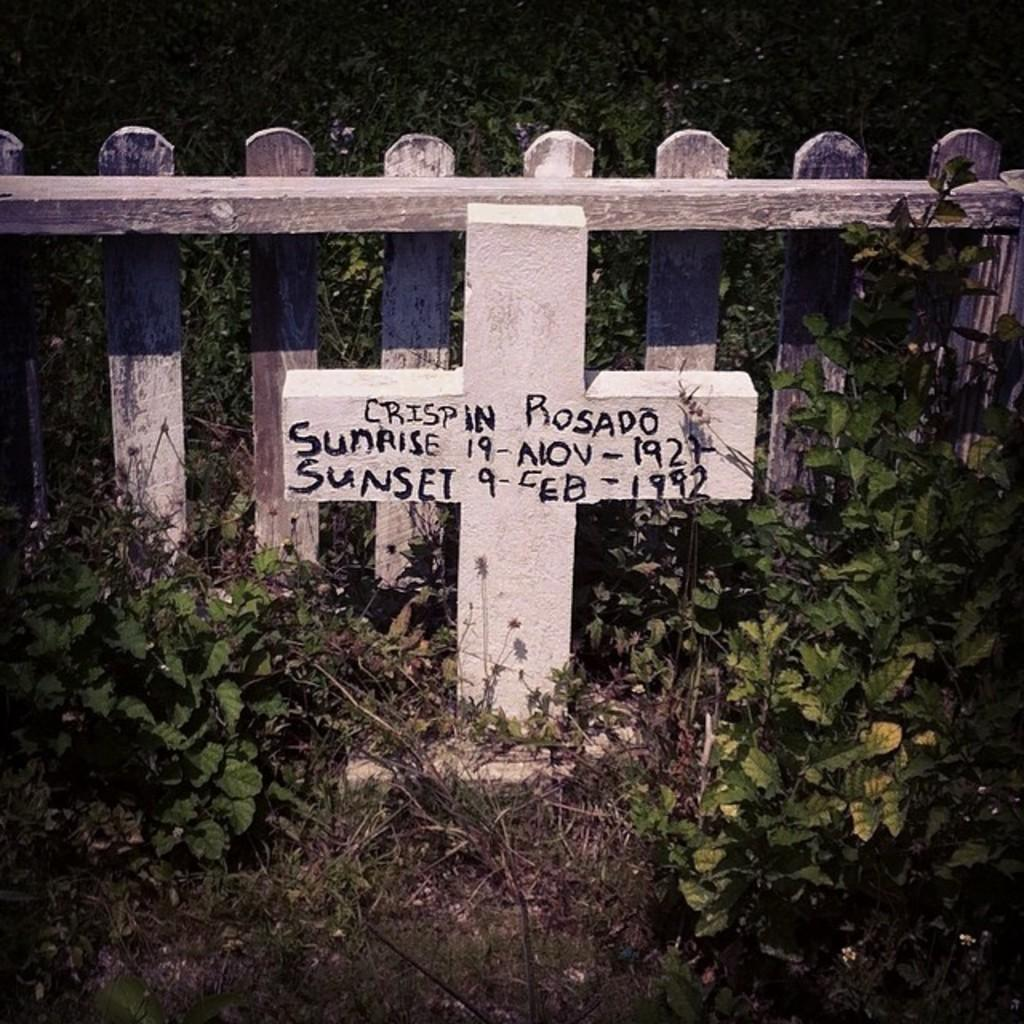What type of barrier can be seen in the image? There is a fence in the image. What is the white object with text in the image? It is not specified what the white object with text is, but it is present in the image. What can be seen beneath the fence and the white object? The ground is visible in the image. What type of vegetation is present in the image? There is grass and plants in the image. What color is the paint on the paper in the image? There is no paint or paper present in the image. How does the anger in the image manifest itself? There is no indication of anger in the image. 